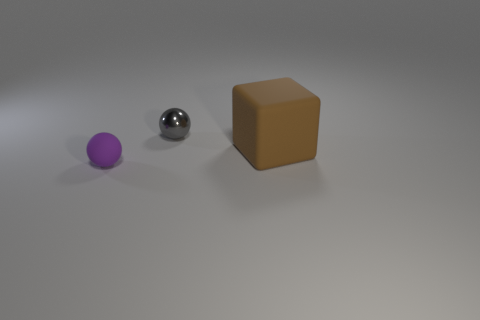There is a object that is both to the right of the purple matte thing and in front of the metal object; what is its color?
Ensure brevity in your answer.  Brown. Is there anything else of the same color as the big thing?
Provide a short and direct response. No. What color is the small ball that is behind the rubber thing in front of the large block?
Give a very brief answer. Gray. Do the metallic object and the rubber ball have the same size?
Offer a very short reply. Yes. Are the object that is to the left of the small metal sphere and the object to the right of the small gray object made of the same material?
Give a very brief answer. Yes. There is a object to the right of the sphere that is behind the tiny purple ball left of the big thing; what is its shape?
Make the answer very short. Cube. Is the number of blocks greater than the number of things?
Your answer should be compact. No. Is there a big blue rubber thing?
Offer a terse response. No. How many things are either tiny things that are to the right of the tiny rubber thing or tiny balls that are on the right side of the purple object?
Provide a short and direct response. 1. Is the number of small gray metallic objects less than the number of rubber objects?
Your response must be concise. Yes. 